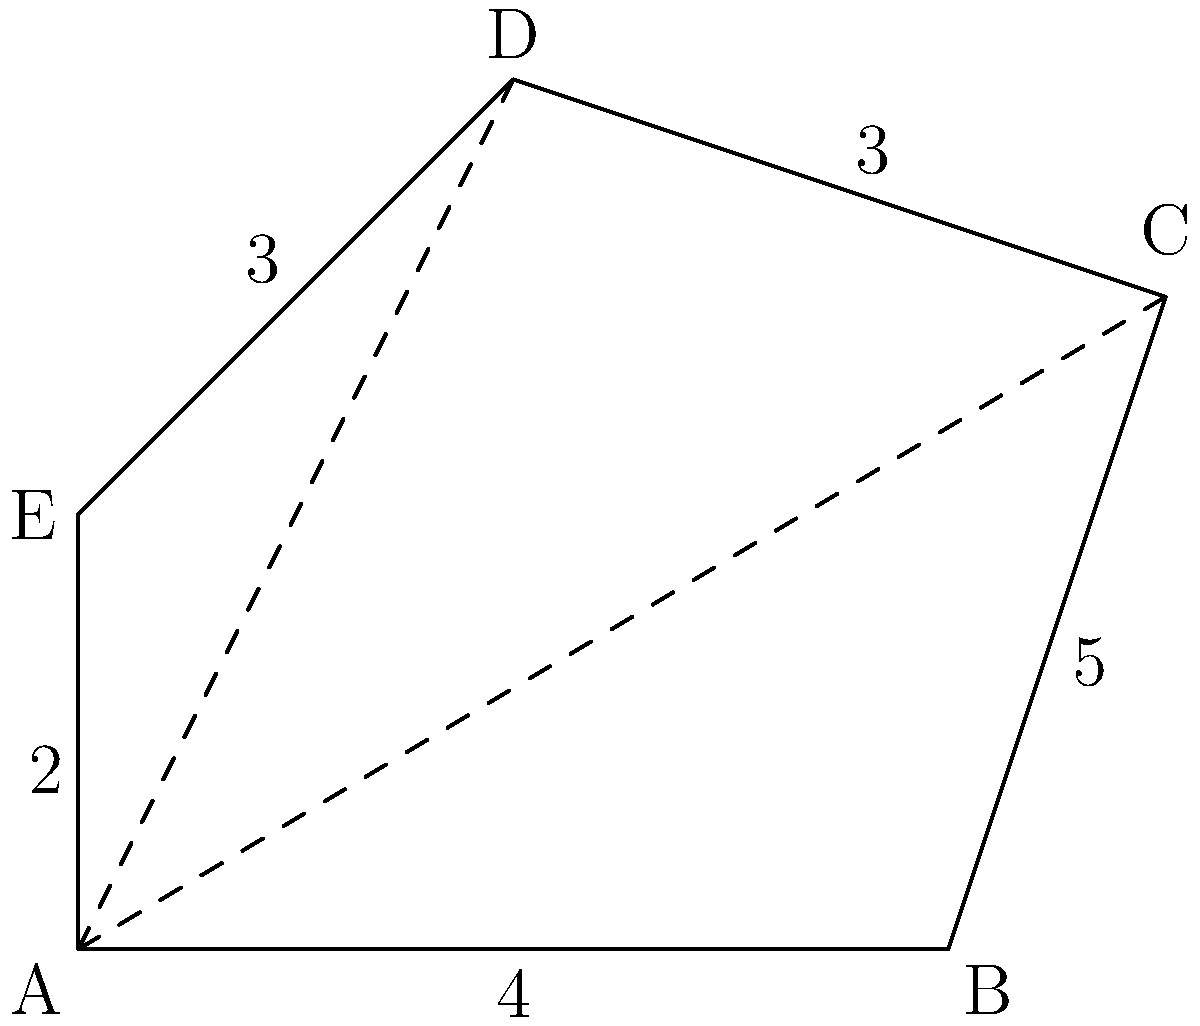In your work with community planning, you come across an irregularly shaped plot of land represented by the polygon ABCDE. To determine the resources needed for a community garden project, you need to calculate the area of this plot. Using trigonometric functions, how would you find the area of this irregular polygon? To find the area of the irregular polygon ABCDE, we can use the following steps:

1) Divide the polygon into triangles by drawing diagonals from vertex A to C and D.

2) Calculate the areas of these triangles using trigonometric functions.

3) For triangle ABC:
   - We know the base (AB = 4) and can find angle BAC using the cosine law:
     $$\cos(BAC) = \frac{AB^2 + AE^2 - BE^2}{2(AB)(AE)} = \frac{4^2 + 2^2 - 5^2}{2(4)(2)} = -0.6875$$
   - $BAC = \arccos(-0.6875) \approx 2.4980$ radians
   - Area of ABC = $\frac{1}{2} \cdot 4 \cdot 5 \cdot \sin(2.4980) \approx 9.2820$ sq units

4) For triangle ACD:
   - We can find AC using the Pythagorean theorem: $AC = \sqrt{4^2 + 3^2} = 5$
   - Angle CAD = $\pi - BAC - BCA$
     where $BCA = \arctan(\frac{3}{1}) \approx 1.2490$ radians
   - CAD $\approx \pi - 2.4980 - 1.2490 \approx 1.3362$ radians
   - Area of ACD = $\frac{1}{2} \cdot 5 \cdot 3 \cdot \sin(1.3362) \approx 7.0711$ sq units

5) For triangle ADE:
   - We know all sides (AD = 4, DE = 3, AE = 2)
   - Use Heron's formula: $Area = \sqrt{s(s-a)(s-b)(s-c)}$
     where $s = \frac{a+b+c}{2} = \frac{4+3+2}{2} = 4.5$
   - Area of ADE = $\sqrt{4.5(4.5-4)(4.5-3)(4.5-2)} \approx 2.9047$ sq units

6) The total area is the sum of these three triangles:
   Total Area $\approx 9.2820 + 7.0711 + 2.9047 = 19.2578$ sq units
Answer: 19.2578 square units 